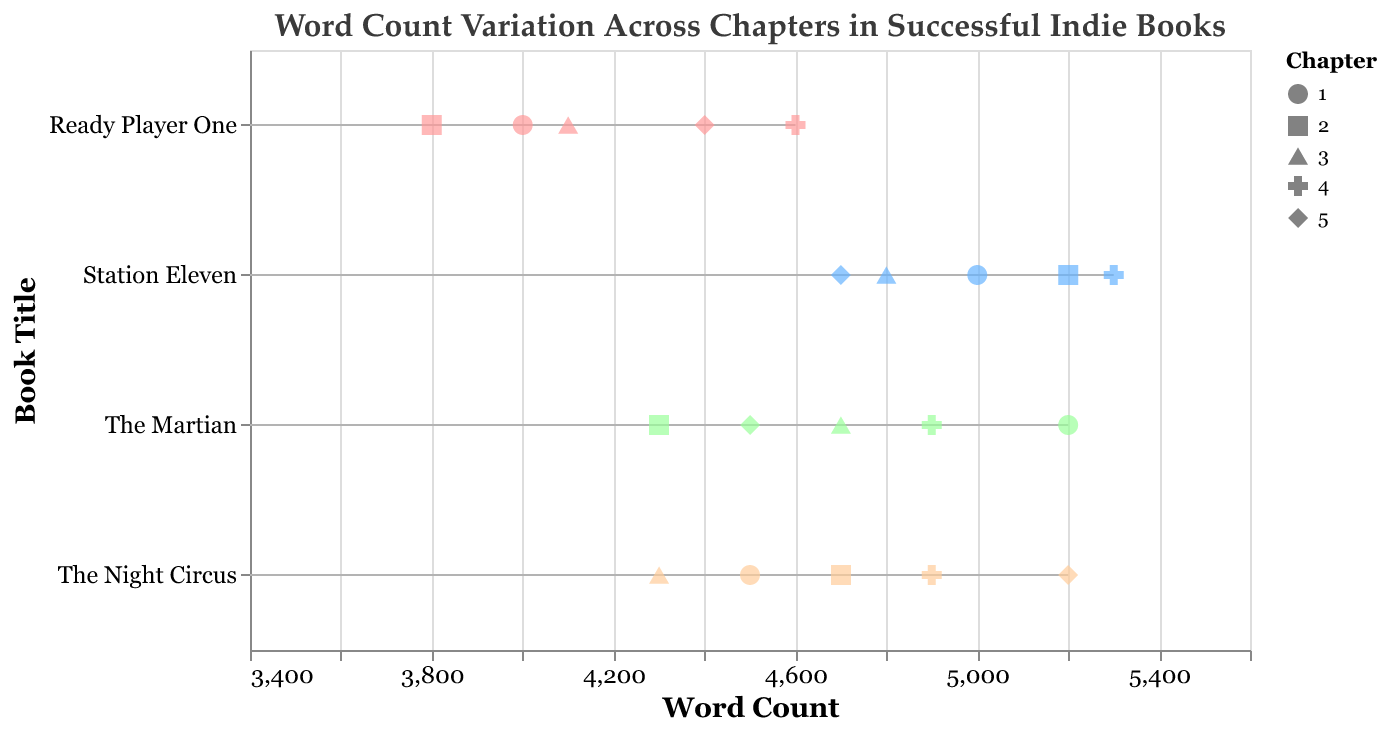What is the range of word counts for "The Martian"? To determine the range of word counts for "The Martian," we look at the maximum and minimum word counts across all chapters. The highest word count is 5200 (Chapter 1) and the lowest is 4300 (Chapter 2). The range is calculated as 5200 - 4300.
Answer: 900 Which book has the highest word count in any chapter? We examine the word counts for each book and identify the highest value. "Station Eleven" has the highest word count in Chapter 4, with 5300 words.
Answer: Station Eleven What is the average word count for "Ready Player One"? Taking all word counts for "Ready Player One" and calculating the average: (4000 + 3800 + 4100 + 4600 + 4400) / 5. This sums up to 20900, and dividing by 5 gives the average.
Answer: 4180 In "The Night Circus," which chapter has the lowest word count? We look at each chapter's word count for "The Night Circus": 4500 (Chapter 1), 4700 (Chapter 2), 4300 (Chapter 3), 4900 (Chapter 4), and 5200 (Chapter 5). The lowest word count is 4300, which occurs in Chapter 3.
Answer: Chapter 3 Compare the average word counts of the first chapters of all books. Which one has the lowest? Calculate the average word count for the first chapter of each book: "The Martian" (5200), "Ready Player One" (4000), "Station Eleven" (5000), and "The Night Circus" (4500). The lowest among these is for "Ready Player One."
Answer: Ready Player One How does the word count of the last chapter of each book compare? Examine the word counts for the last chapters: "The Martian" (4500), "Ready Player One" (4400), "Station Eleven" (4700), "The Night Circus" (5200). The order from least to greatest is: 4400, 4500, 4700, 5200.
Answer: Ready Player One < The Martian < Station Eleven < The Night Circus Which book has the most consistent word count across its chapters? To determine consistency, compare the variance of word counts for each book. Calculate the range (max - min) for each: "The Martian" (900), "Ready Player One" (800), "Station Eleven" (500), "The Night Circus" (900). "Station Eleven" has the smallest range and thus the most consistent word count.
Answer: Station Eleven If you were to read all the second chapters, which book would you spend the most time on, assuming reading speed is proportional to word count? Examining the word counts for all the second chapters: "The Martian" (4300), "Ready Player One" (3800), "Station Eleven" (5200), and "The Night Circus" (4700). The highest word count is in "Station Eleven."
Answer: Station Eleven Looking at the fourth chapters, which book shows the highest disparity compared to its other chapters' word counts? Compare the fourth chapter's word count with the average word count of the other chapters for each book. "The Martian": 5200 + 4300 + 4700 + 4500 = 18700/4 = 4675 (4900 vs 4675, disparity = 225). "Ready Player One": 4000 + 3800 + 4100 + 4400 = 16300/4 = 4075 (4600 vs 4075, disparity = 525). "Station Eleven": 5000 + 5200 + 4800 + 4700 = 19700/4 = 4925 (5300 vs 4925, disparity = 375). "The Night Circus": 4500 + 4700 + 4300 + 5200 = 18700/4 = 4675 (4900 vs 4675, disparity = 225). "Ready Player One" fourth chapter has the highest disparity of 525.
Answer: Ready Player One 